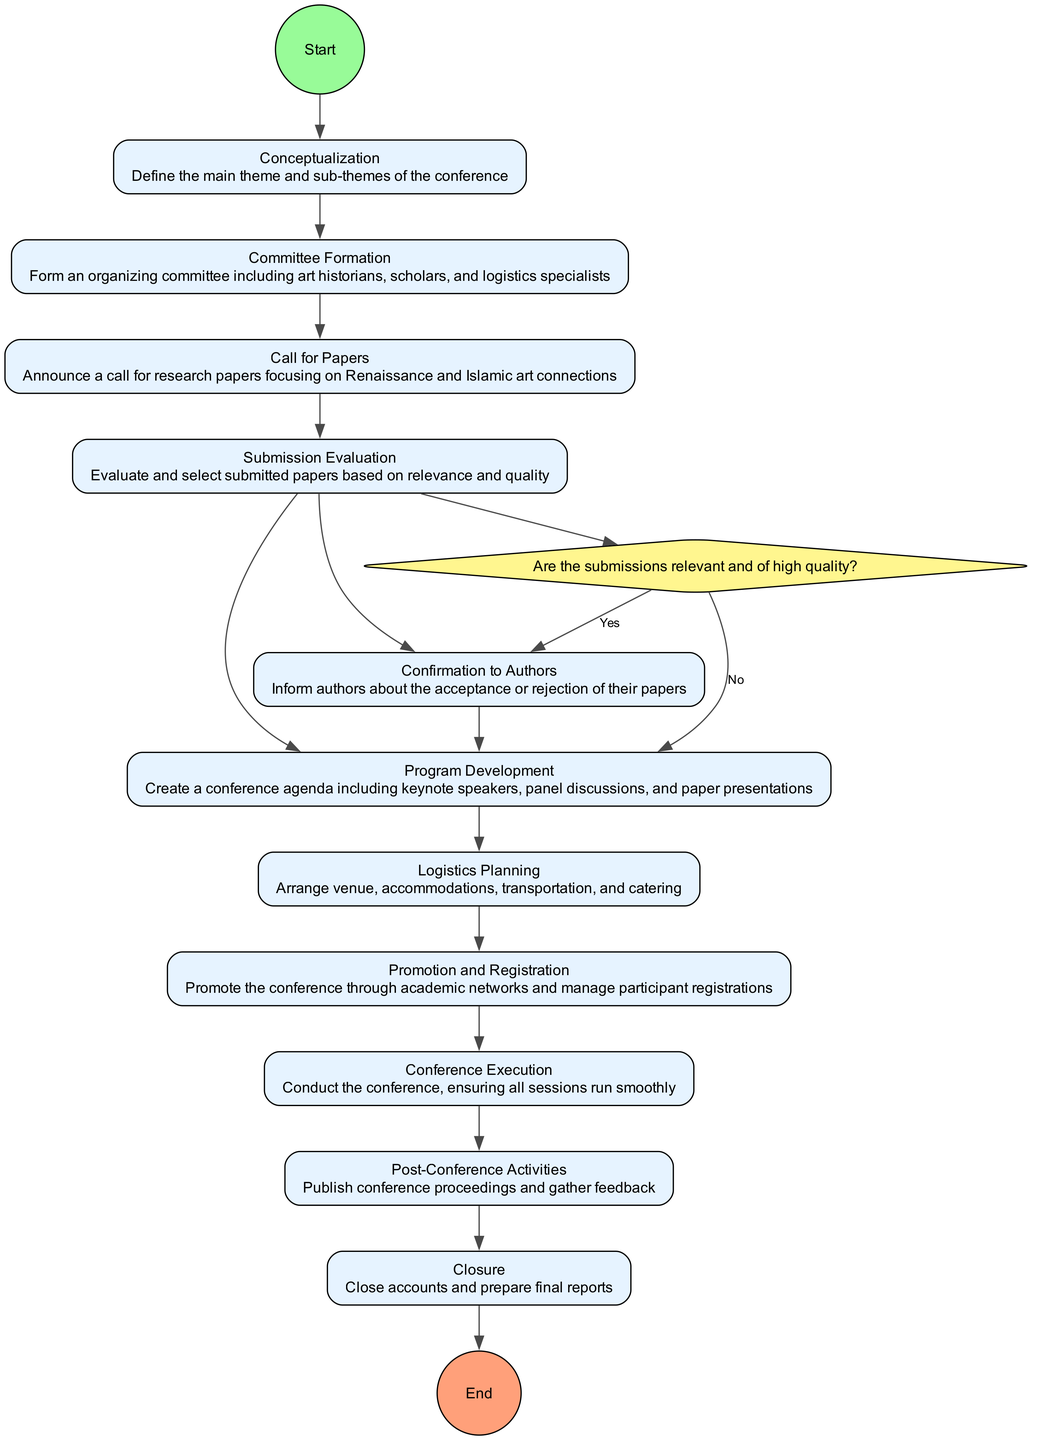What is the first activity in the diagram? The first activity shown in the diagram is labeled "Conceptualization," which is the starting point of the flow.
Answer: Conceptualization How many total activities are outlined in the diagram? The diagram includes a total of 11 activities, concluding with "Closure."
Answer: 11 Which activity follows "Committee Formation"? Following "Committee Formation," the next activity in the sequence is "Call for Papers." This can be traced directly through the transition indicated in the diagram.
Answer: Call for Papers What decision is made after "Submission Evaluation"? The decision made after "Submission Evaluation" is whether submissions are relevant and of high quality, leading to confirmation for authors or program development.
Answer: Evaluate Submissions If the submission is not accepted, which activity is next? If the submission is evaluated as not relevant or of low quality, the next activity is "Program Development," as specified in the decision branches.
Answer: Program Development What are the last two activities before reaching "Closure"? The last two activities before "Closure" are "Post-Conference Activities" and "Conference Execution," leading in that order.
Answer: Post-Conference Activities, Conference Execution How many branches stem from the "Evaluate Submissions" decision? The "Evaluate Submissions" decision has two branches: one for "Yes" and another for "No," indicating two possible outcomes from the evaluation.
Answer: 2 What is the final output or conclusion of the entire process depicted in the diagram? The final output of the process is "Closure," which indicates that all activities have been completed and accounts finalized, concluding the conference organization.
Answer: Closure What type of specialists are included in "Committee Formation"? The specialists included in "Committee Formation" are art historians, scholars, and logistics specialists, as detailed in the activity description.
Answer: Art historians, scholars, and logistics specialists What is the main purpose of "Promotion and Registration"? The main purpose of "Promotion and Registration" is to promote the conference through academic networks and manage participant registrations, as outlined in the activity details.
Answer: Promote the conference and manage registrations 